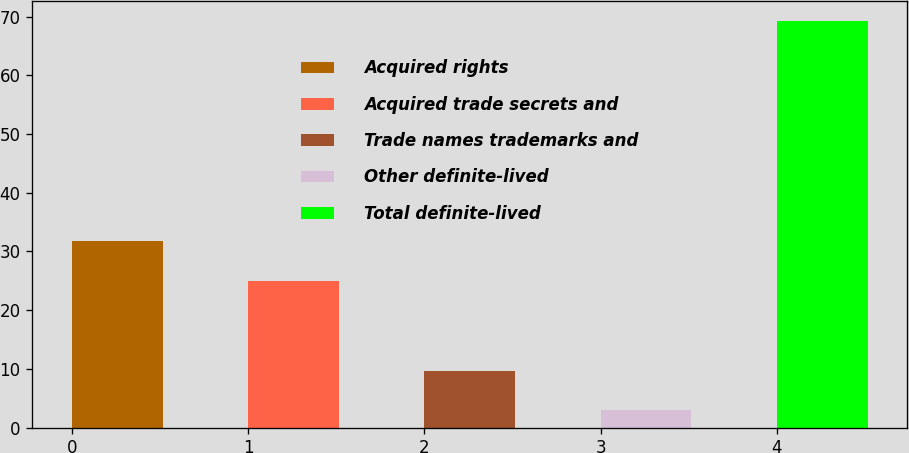Convert chart to OTSL. <chart><loc_0><loc_0><loc_500><loc_500><bar_chart><fcel>Acquired rights<fcel>Acquired trade secrets and<fcel>Trade names trademarks and<fcel>Other definite-lived<fcel>Total definite-lived<nl><fcel>31.7<fcel>24.9<fcel>9.7<fcel>2.9<fcel>69.2<nl></chart> 